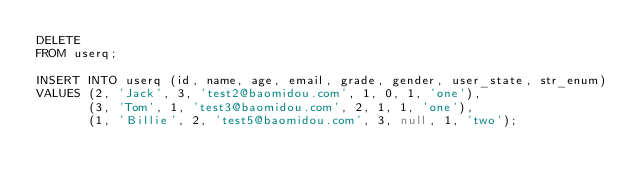Convert code to text. <code><loc_0><loc_0><loc_500><loc_500><_SQL_>DELETE
FROM userq;

INSERT INTO userq (id, name, age, email, grade, gender, user_state, str_enum)
VALUES (2, 'Jack', 3, 'test2@baomidou.com', 1, 0, 1, 'one'),
       (3, 'Tom', 1, 'test3@baomidou.com', 2, 1, 1, 'one'),
       (1, 'Billie', 2, 'test5@baomidou.com', 3, null, 1, 'two');</code> 